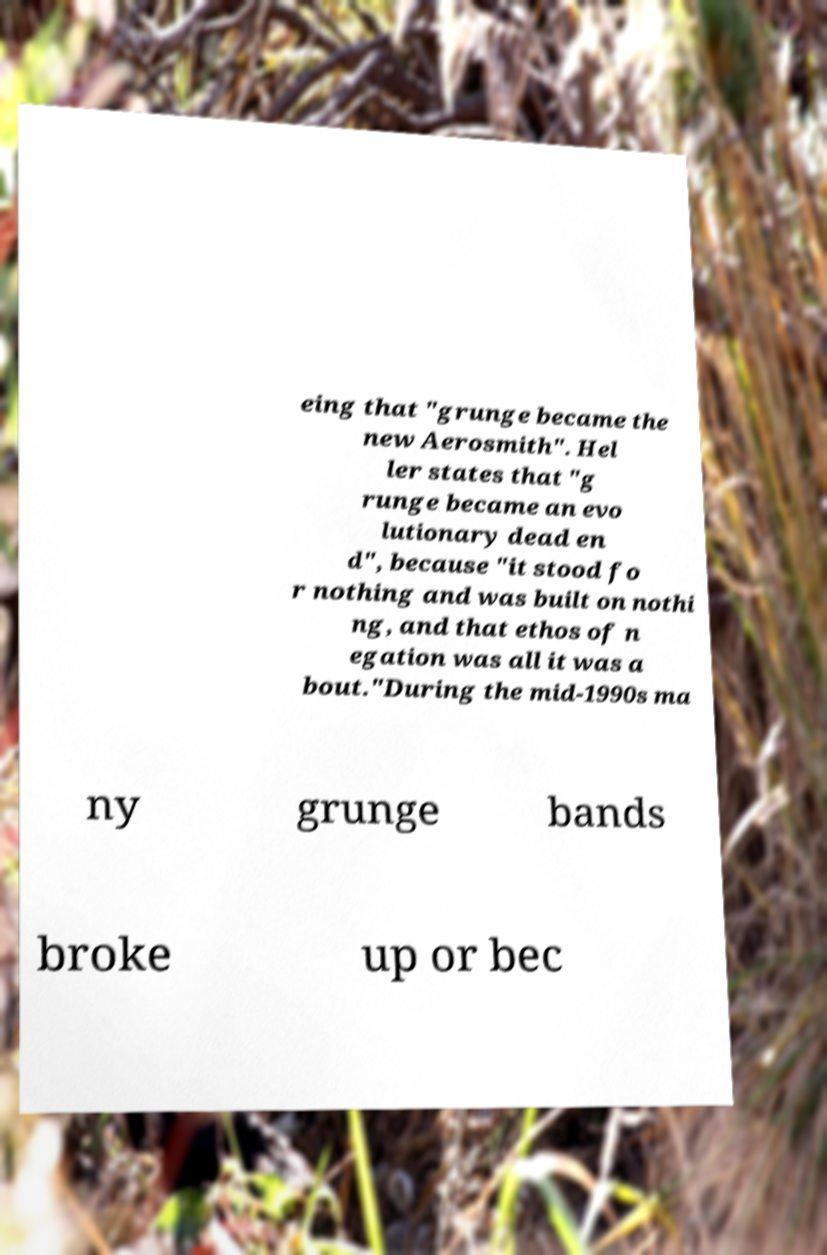Can you read and provide the text displayed in the image?This photo seems to have some interesting text. Can you extract and type it out for me? eing that "grunge became the new Aerosmith". Hel ler states that "g runge became an evo lutionary dead en d", because "it stood fo r nothing and was built on nothi ng, and that ethos of n egation was all it was a bout."During the mid-1990s ma ny grunge bands broke up or bec 